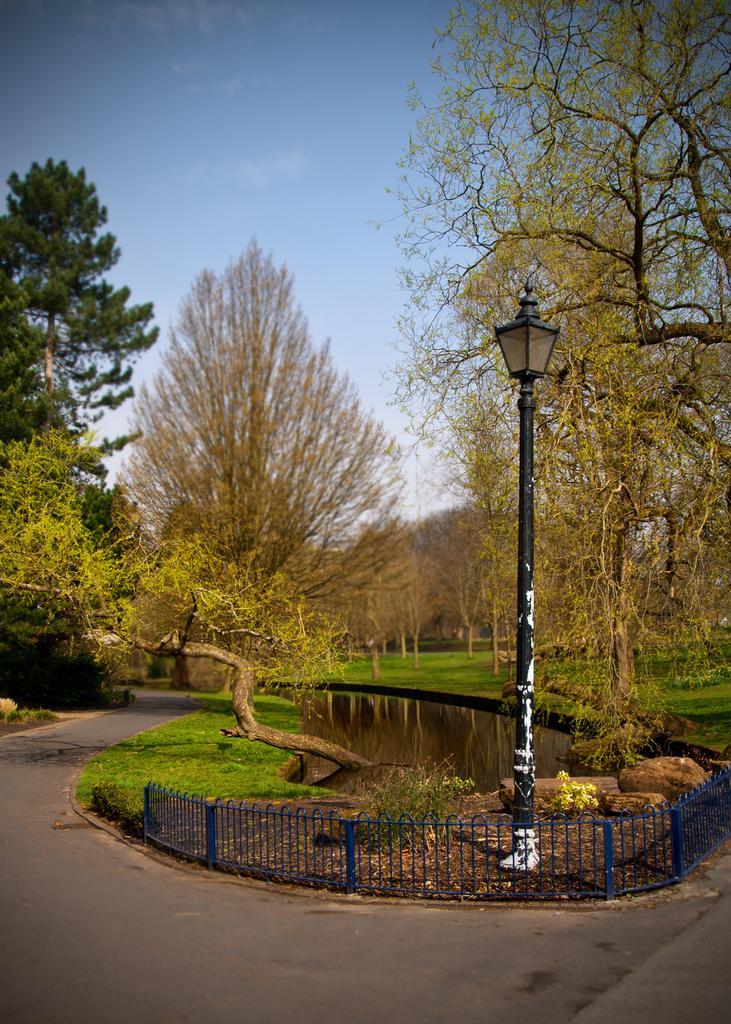Please provide a concise description of this image. This image consists of many trees. At the bottom, there is a road. In the middle, there is water and fencing. In the front, there is a pole. At the top, there is sky. 